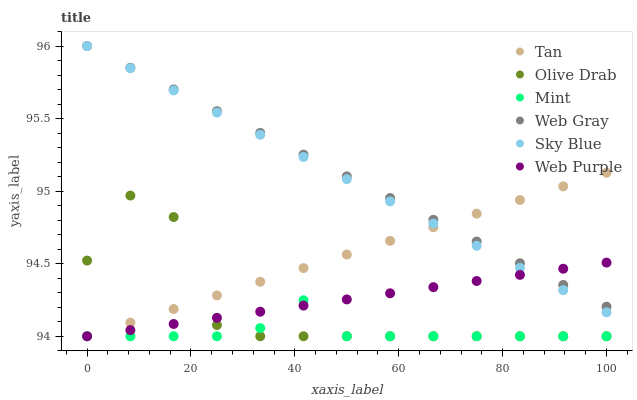Does Mint have the minimum area under the curve?
Answer yes or no. Yes. Does Web Gray have the maximum area under the curve?
Answer yes or no. Yes. Does Web Purple have the minimum area under the curve?
Answer yes or no. No. Does Web Purple have the maximum area under the curve?
Answer yes or no. No. Is Web Purple the smoothest?
Answer yes or no. Yes. Is Olive Drab the roughest?
Answer yes or no. Yes. Is Sky Blue the smoothest?
Answer yes or no. No. Is Sky Blue the roughest?
Answer yes or no. No. Does Web Purple have the lowest value?
Answer yes or no. Yes. Does Sky Blue have the lowest value?
Answer yes or no. No. Does Sky Blue have the highest value?
Answer yes or no. Yes. Does Web Purple have the highest value?
Answer yes or no. No. Is Olive Drab less than Sky Blue?
Answer yes or no. Yes. Is Web Gray greater than Mint?
Answer yes or no. Yes. Does Sky Blue intersect Tan?
Answer yes or no. Yes. Is Sky Blue less than Tan?
Answer yes or no. No. Is Sky Blue greater than Tan?
Answer yes or no. No. Does Olive Drab intersect Sky Blue?
Answer yes or no. No. 